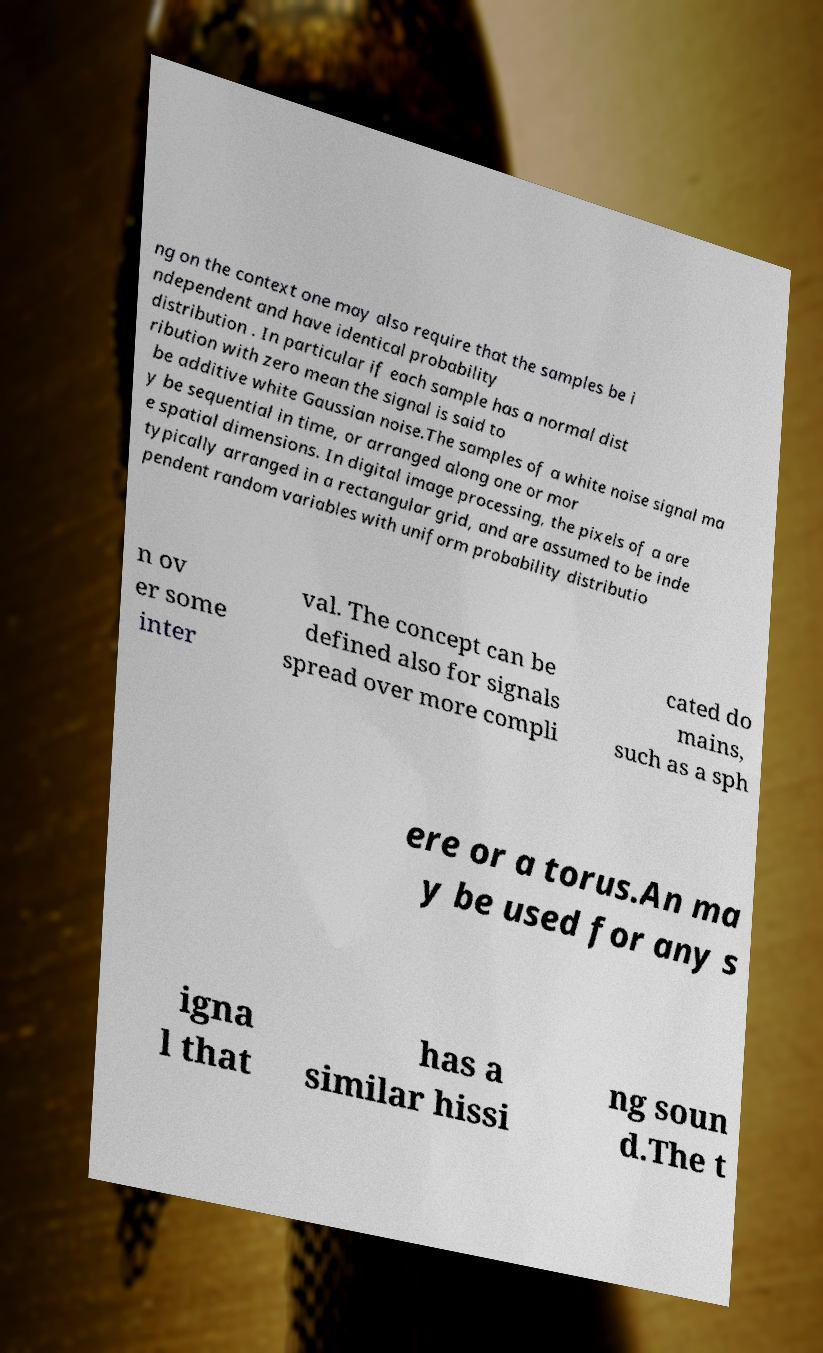Could you extract and type out the text from this image? ng on the context one may also require that the samples be i ndependent and have identical probability distribution . In particular if each sample has a normal dist ribution with zero mean the signal is said to be additive white Gaussian noise.The samples of a white noise signal ma y be sequential in time, or arranged along one or mor e spatial dimensions. In digital image processing, the pixels of a are typically arranged in a rectangular grid, and are assumed to be inde pendent random variables with uniform probability distributio n ov er some inter val. The concept can be defined also for signals spread over more compli cated do mains, such as a sph ere or a torus.An ma y be used for any s igna l that has a similar hissi ng soun d.The t 